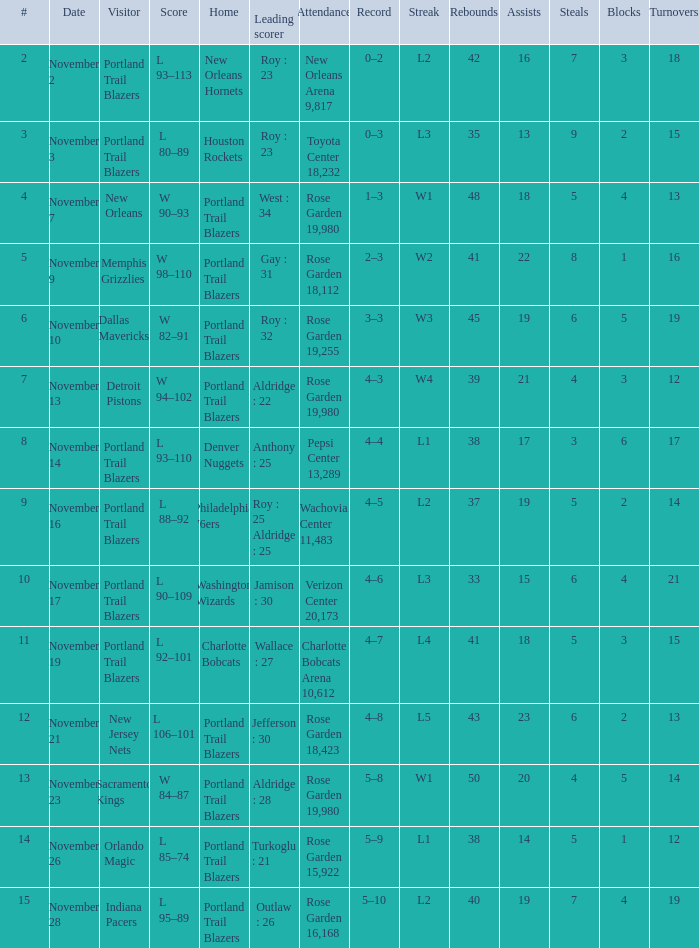Could you help me parse every detail presented in this table? {'header': ['#', 'Date', 'Visitor', 'Score', 'Home', 'Leading scorer', 'Attendance', 'Record', 'Streak', 'Rebounds', 'Assists', 'Steals', 'Blocks', 'Turnovers'], 'rows': [['2', 'November 2', 'Portland Trail Blazers', 'L 93–113', 'New Orleans Hornets', 'Roy : 23', 'New Orleans Arena 9,817', '0–2', 'L2', '42', '16', '7', '3', '18'], ['3', 'November 3', 'Portland Trail Blazers', 'L 80–89', 'Houston Rockets', 'Roy : 23', 'Toyota Center 18,232', '0–3', 'L3', '35', '13', '9', '2', '15'], ['4', 'November 7', 'New Orleans', 'W 90–93', 'Portland Trail Blazers', 'West : 34', 'Rose Garden 19,980', '1–3', 'W1', '48', '18', '5', '4', '13'], ['5', 'November 9', 'Memphis Grizzlies', 'W 98–110', 'Portland Trail Blazers', 'Gay : 31', 'Rose Garden 18,112', '2–3', 'W2', '41', '22', '8', '1', '16'], ['6', 'November 10', 'Dallas Mavericks', 'W 82–91', 'Portland Trail Blazers', 'Roy : 32', 'Rose Garden 19,255', '3–3', 'W3', '45', '19', '6', '5', '19'], ['7', 'November 13', 'Detroit Pistons', 'W 94–102', 'Portland Trail Blazers', 'Aldridge : 22', 'Rose Garden 19,980', '4–3', 'W4', '39', '21', '4', '3', '12'], ['8', 'November 14', 'Portland Trail Blazers', 'L 93–110', 'Denver Nuggets', 'Anthony : 25', 'Pepsi Center 13,289', '4–4', 'L1', '38', '17', '3', '6', '17'], ['9', 'November 16', 'Portland Trail Blazers', 'L 88–92', 'Philadelphia 76ers', 'Roy : 25 Aldridge : 25', 'Wachovia Center 11,483', '4–5', 'L2', '37', '19', '5', '2', '14'], ['10', 'November 17', 'Portland Trail Blazers', 'L 90–109', 'Washington Wizards', 'Jamison : 30', 'Verizon Center 20,173', '4–6', 'L3', '33', '15', '6', '4', '21'], ['11', 'November 19', 'Portland Trail Blazers', 'L 92–101', 'Charlotte Bobcats', 'Wallace : 27', 'Charlotte Bobcats Arena 10,612', '4–7', 'L4', '41', '18', '5', '3', '15'], ['12', 'November 21', 'New Jersey Nets', 'L 106–101', 'Portland Trail Blazers', 'Jefferson : 30', 'Rose Garden 18,423', '4–8', 'L5', '43', '23', '6', '2', '13'], ['13', 'November 23', 'Sacramento Kings', 'W 84–87', 'Portland Trail Blazers', 'Aldridge : 28', 'Rose Garden 19,980', '5–8', 'W1', '50', '20', '4', '5', '14'], ['14', 'November 26', 'Orlando Magic', 'L 85–74', 'Portland Trail Blazers', 'Turkoglu : 21', 'Rose Garden 15,922', '5–9', 'L1', '38', '14', '5', '1', '12'], ['15', 'November 28', 'Indiana Pacers', 'L 95–89', 'Portland Trail Blazers', 'Outlaw : 26', 'Rose Garden 16,168', '5–10', 'L2', '40', '19', '7', '4', '19']]}  what's the score where record is 0–2 L 93–113. 